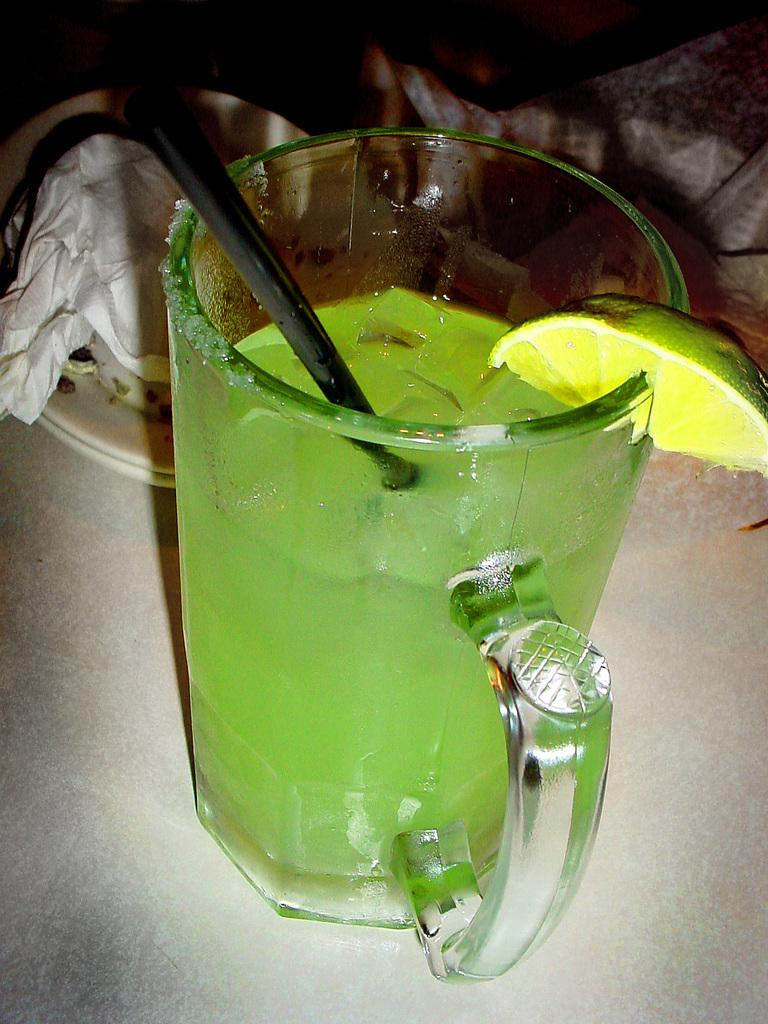What type of fruit is in the image? There is a lemon in the image. What is the glass with a straw used for? The glass contains a drink. Where is the glass located? The glass is on a surface. What can be seen in the background of the image? There are plates, tissue paper, and other objects visible in the background. What day of the week is it in the image? The day of the week is not visible or mentioned in the image. Is there a sink present in the image? There is no sink visible in the image. 